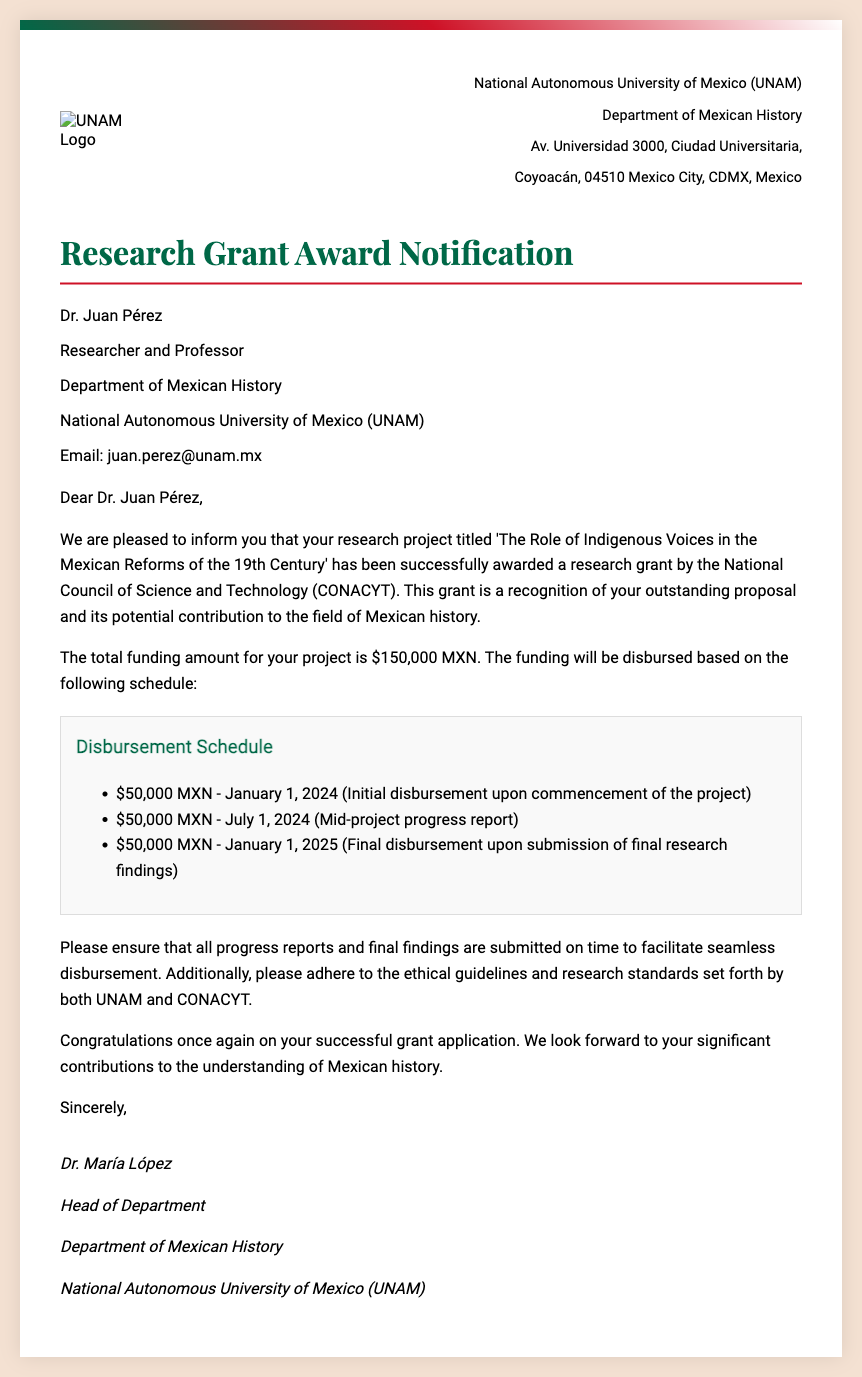What is the title of the research project? The title of the research project is mentioned in the letter as 'The Role of Indigenous Voices in the Mexican Reforms of the 19th Century.'
Answer: The Role of Indigenous Voices in the Mexican Reforms of the 19th Century Who issued the research grant? The document states that the grant was awarded by the National Council of Science and Technology (CONACYT).
Answer: National Council of Science and Technology (CONACYT) What is the total funding amount? The total funding amount is explicitly mentioned in the document as $150,000 MXN.
Answer: $150,000 MXN When is the initial disbursement scheduled? The document outlines that the initial disbursement is scheduled for January 1, 2024.
Answer: January 1, 2024 Who is the head of the department? The letter indicates that Dr. María López is the head of the department.
Answer: Dr. María López What is required for the mid-project disbursement? According to the document, the mid-project disbursement is contingent upon the submission of a progress report.
Answer: Progress report When is the final disbursement due? The document specifies that the final disbursement is scheduled for January 1, 2025.
Answer: January 1, 2025 What department is Dr. Juan Pérez associated with? The document states that Dr. Juan Pérez is associated with the Department of Mexican History.
Answer: Department of Mexican History What must be submitted to facilitate seamless disbursement? The document specifies that all progress reports and final findings must be submitted on time.
Answer: Progress reports and final findings 